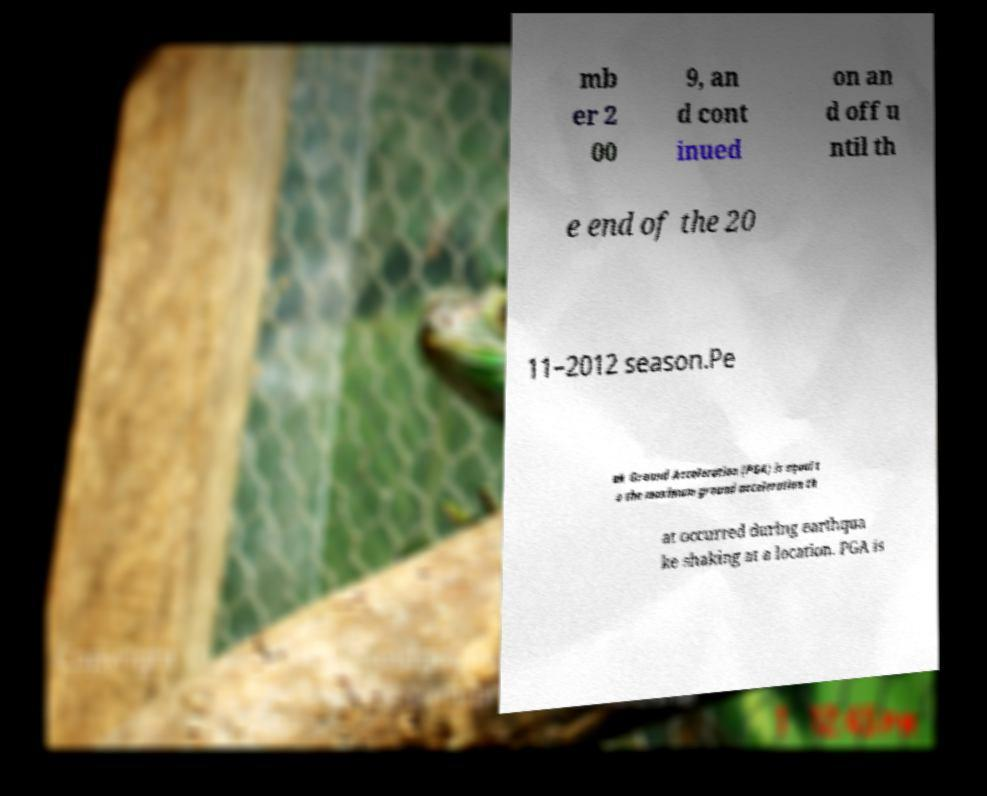Please identify and transcribe the text found in this image. mb er 2 00 9, an d cont inued on an d off u ntil th e end of the 20 11–2012 season.Pe ak Ground Acceleration (PGA) is equal t o the maximum ground acceleration th at occurred during earthqua ke shaking at a location. PGA is 